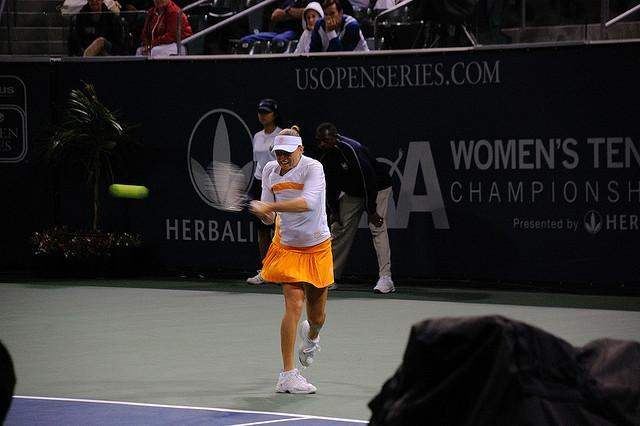Where is this tournament based? Please explain your reasoning. flushing meadows. The writing on the wall indicates that this is the us open. this tournament is based in new york city. 